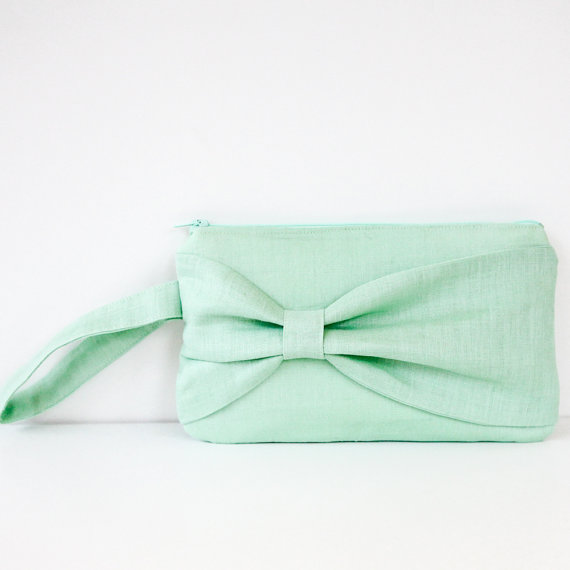Describe a realistic scenario where this clutch purse could be the perfect gift. Why would it be appreciated? A realistic scenario where this clutch purse could be the perfect gift is at a bridal shower for a bride-to-be. The soft mint green color fits well with wedding themes and can symbolize new beginnings and tranquility. The elegant bow adds a touch of charm that the bride can appreciate, making it both a practical and sentimental gift. The wrist strap offers convenience, making it easy for the bride to carry it during her many pre-wedding events such as engagement parties or rehearsal dinners. The purse's versatile design ensures that it can be used for other special occasions long after the wedding, making it a cherished and useful addition to her wardrobe. 